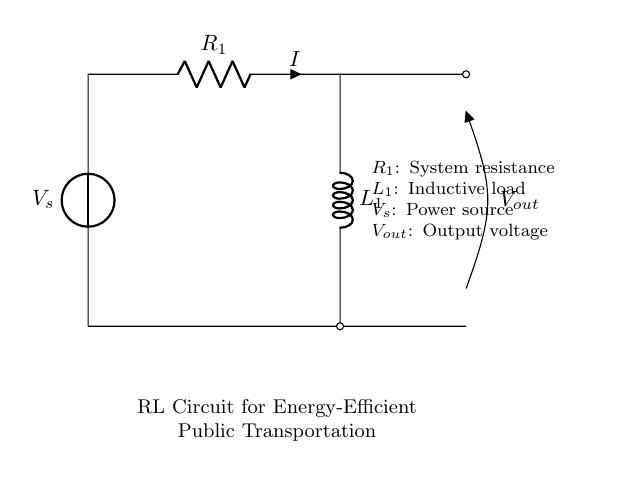What are the components of this circuit? The circuit contains a voltage source, a resistor, and an inductor. Each is represented in the diagram: V_s is the voltage source, R_1 is the resistor, and L_1 is the inductor.
Answer: Voltage source, resistor, inductor What is the purpose of the inductor in this circuit? In this resistor-inductor circuit, the inductor helps reduce fluctuations in current, smoothing the energy delivery and improving efficiency. This is particularly useful in public transportation systems to ensure stable power supply.
Answer: Smooths current What is the value of the output voltage labeled in the circuit? The output voltage is denoted as V_out in the circuit diagram; however, the specific numerical value is not provided, it's labeled for reference.
Answer: V_out How does the presence of resistance affect the circuit's energy efficiency? Resistance R_1 dissipates energy in the form of heat, which can decrease the overall efficiency of energy transfer in the circuit. Lower resistance can help improve energy efficiency, making the system more effective for public transportation applications.
Answer: Decreases efficiency What type of circuit is represented here? The circuit shown is a resistor-inductor circuit, which combines resistive and inductive components to manage current and improve energy efficiency in systems like public transportation.
Answer: Resistor-inductor circuit What does the symbol labeled V_s represent in the circuit? The symbol V_s represents the voltage source, which provides the electrical power necessary for the circuit to function and is critical in supplying energy for the resistive and inductive loads.
Answer: Voltage source How does the inductor improve the performance of public transportation systems? The inductor stores energy in its magnetic field, releasing it when needed, which improves efficiency by stabilizing the power supply and reducing energy waste. This allows for smoother operation of electric-powered vehicles, enhancing their overall performance and reliability.
Answer: Stabilizes power supply 